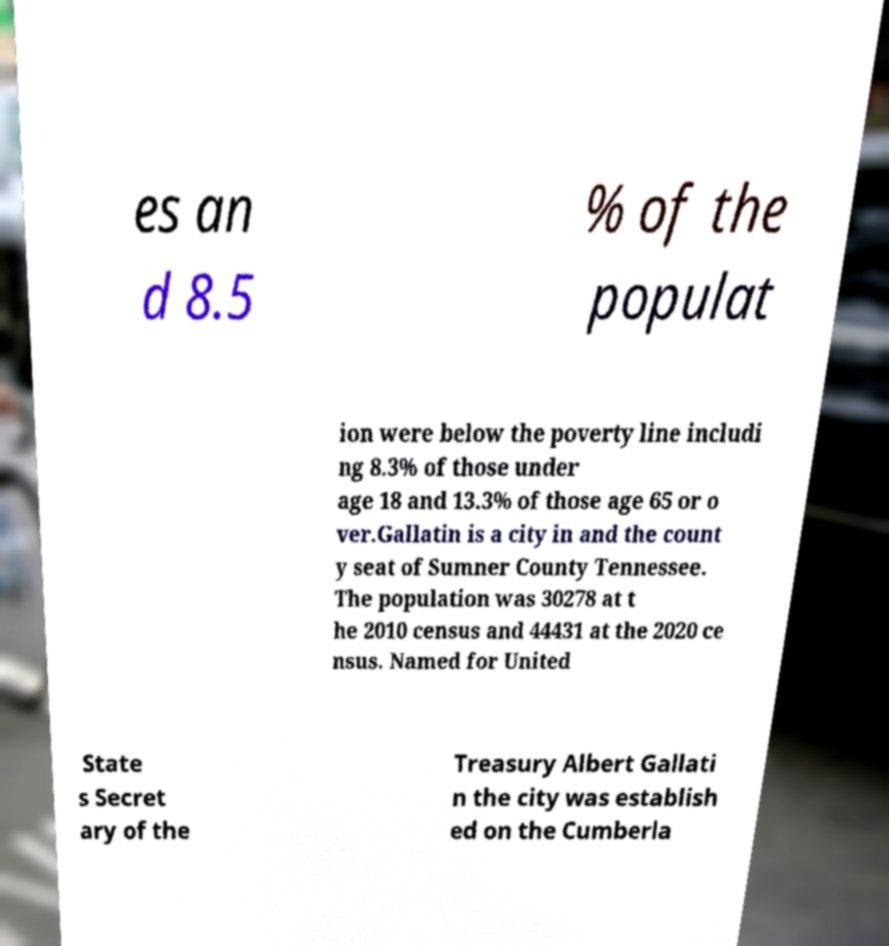Please read and relay the text visible in this image. What does it say? es an d 8.5 % of the populat ion were below the poverty line includi ng 8.3% of those under age 18 and 13.3% of those age 65 or o ver.Gallatin is a city in and the count y seat of Sumner County Tennessee. The population was 30278 at t he 2010 census and 44431 at the 2020 ce nsus. Named for United State s Secret ary of the Treasury Albert Gallati n the city was establish ed on the Cumberla 